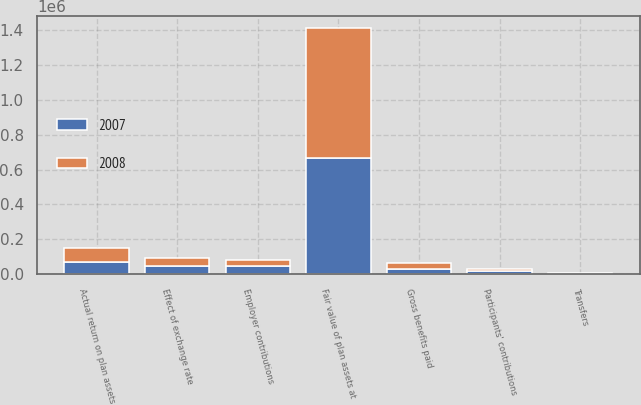<chart> <loc_0><loc_0><loc_500><loc_500><stacked_bar_chart><ecel><fcel>Fair value of plan assets at<fcel>Actual return on plan assets<fcel>Employer contributions<fcel>Participants' contributions<fcel>Gross benefits paid<fcel>Transfers<fcel>Effect of exchange rate<nl><fcel>2007<fcel>664699<fcel>67247<fcel>47046<fcel>15518<fcel>29565<fcel>2679<fcel>46581<nl><fcel>2008<fcel>746189<fcel>81483<fcel>34937<fcel>14367<fcel>32486<fcel>1868<fcel>44930<nl></chart> 